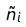Convert formula to latex. <formula><loc_0><loc_0><loc_500><loc_500>\tilde { n } _ { i }</formula> 